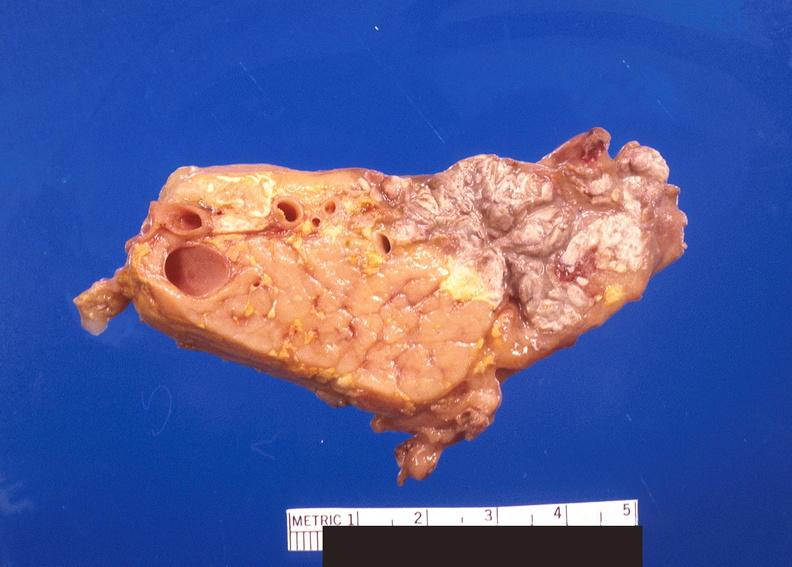what does this image show?
Answer the question using a single word or phrase. Pancreatic fat necrosis 